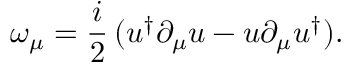Convert formula to latex. <formula><loc_0><loc_0><loc_500><loc_500>\omega _ { \mu } = \frac { i } { 2 } \, ( u ^ { \dag } \partial _ { \mu } u - u \partial _ { \mu } u ^ { \dag } ) .</formula> 